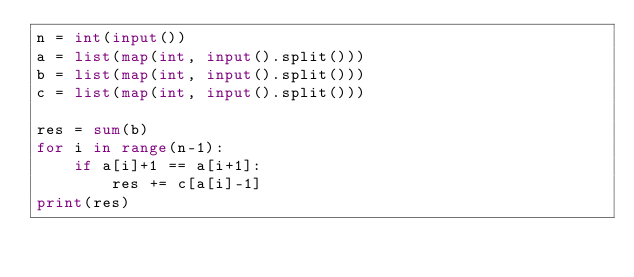<code> <loc_0><loc_0><loc_500><loc_500><_Python_>n = int(input())
a = list(map(int, input().split()))
b = list(map(int, input().split()))
c = list(map(int, input().split()))

res = sum(b)
for i in range(n-1):
    if a[i]+1 == a[i+1]:
        res += c[a[i]-1]
print(res)</code> 